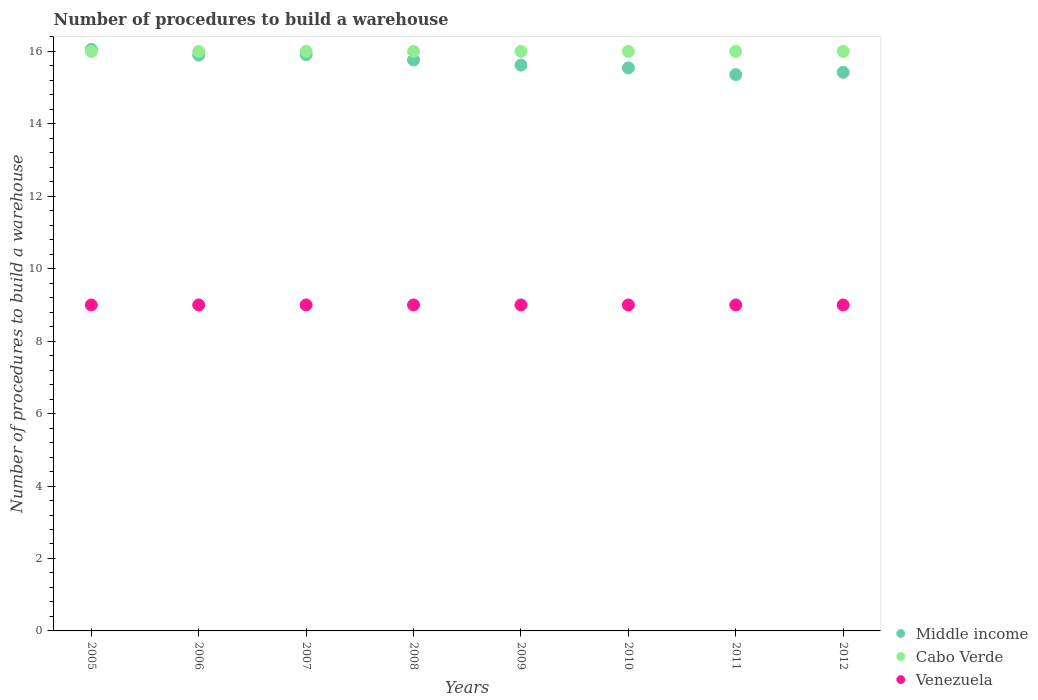How many different coloured dotlines are there?
Give a very brief answer. 3. Is the number of dotlines equal to the number of legend labels?
Provide a succinct answer. Yes. What is the number of procedures to build a warehouse in in Venezuela in 2011?
Your answer should be compact. 9. Across all years, what is the maximum number of procedures to build a warehouse in in Venezuela?
Provide a short and direct response. 9. Across all years, what is the minimum number of procedures to build a warehouse in in Venezuela?
Your answer should be very brief. 9. What is the total number of procedures to build a warehouse in in Middle income in the graph?
Make the answer very short. 125.58. What is the difference between the number of procedures to build a warehouse in in Middle income in 2009 and that in 2010?
Ensure brevity in your answer.  0.08. What is the difference between the number of procedures to build a warehouse in in Middle income in 2008 and the number of procedures to build a warehouse in in Venezuela in 2010?
Give a very brief answer. 6.76. What is the average number of procedures to build a warehouse in in Venezuela per year?
Your answer should be very brief. 9. In the year 2009, what is the difference between the number of procedures to build a warehouse in in Cabo Verde and number of procedures to build a warehouse in in Venezuela?
Give a very brief answer. 7. Is the number of procedures to build a warehouse in in Middle income in 2005 less than that in 2010?
Your answer should be compact. No. Is the difference between the number of procedures to build a warehouse in in Cabo Verde in 2009 and 2012 greater than the difference between the number of procedures to build a warehouse in in Venezuela in 2009 and 2012?
Offer a terse response. No. What is the difference between the highest and the second highest number of procedures to build a warehouse in in Cabo Verde?
Keep it short and to the point. 0. What is the difference between the highest and the lowest number of procedures to build a warehouse in in Venezuela?
Give a very brief answer. 0. Is it the case that in every year, the sum of the number of procedures to build a warehouse in in Cabo Verde and number of procedures to build a warehouse in in Middle income  is greater than the number of procedures to build a warehouse in in Venezuela?
Give a very brief answer. Yes. Is the number of procedures to build a warehouse in in Middle income strictly less than the number of procedures to build a warehouse in in Cabo Verde over the years?
Ensure brevity in your answer.  No. How many dotlines are there?
Provide a short and direct response. 3. Are the values on the major ticks of Y-axis written in scientific E-notation?
Provide a short and direct response. No. Does the graph contain any zero values?
Offer a terse response. No. Does the graph contain grids?
Ensure brevity in your answer.  No. Where does the legend appear in the graph?
Your answer should be compact. Bottom right. How are the legend labels stacked?
Give a very brief answer. Vertical. What is the title of the graph?
Provide a succinct answer. Number of procedures to build a warehouse. Does "Suriname" appear as one of the legend labels in the graph?
Your response must be concise. No. What is the label or title of the Y-axis?
Keep it short and to the point. Number of procedures to build a warehouse. What is the Number of procedures to build a warehouse of Middle income in 2005?
Offer a very short reply. 16.06. What is the Number of procedures to build a warehouse in Middle income in 2006?
Provide a succinct answer. 15.9. What is the Number of procedures to build a warehouse of Cabo Verde in 2006?
Give a very brief answer. 16. What is the Number of procedures to build a warehouse in Middle income in 2007?
Your answer should be very brief. 15.91. What is the Number of procedures to build a warehouse of Cabo Verde in 2007?
Give a very brief answer. 16. What is the Number of procedures to build a warehouse of Venezuela in 2007?
Your answer should be very brief. 9. What is the Number of procedures to build a warehouse in Middle income in 2008?
Your answer should be compact. 15.76. What is the Number of procedures to build a warehouse in Middle income in 2009?
Your answer should be very brief. 15.62. What is the Number of procedures to build a warehouse in Middle income in 2010?
Give a very brief answer. 15.54. What is the Number of procedures to build a warehouse in Venezuela in 2010?
Offer a terse response. 9. What is the Number of procedures to build a warehouse of Middle income in 2011?
Your response must be concise. 15.36. What is the Number of procedures to build a warehouse of Cabo Verde in 2011?
Provide a succinct answer. 16. What is the Number of procedures to build a warehouse in Venezuela in 2011?
Your answer should be very brief. 9. What is the Number of procedures to build a warehouse in Middle income in 2012?
Give a very brief answer. 15.42. What is the Number of procedures to build a warehouse of Venezuela in 2012?
Offer a very short reply. 9. Across all years, what is the maximum Number of procedures to build a warehouse in Middle income?
Provide a short and direct response. 16.06. Across all years, what is the maximum Number of procedures to build a warehouse of Cabo Verde?
Keep it short and to the point. 16. Across all years, what is the minimum Number of procedures to build a warehouse of Middle income?
Keep it short and to the point. 15.36. What is the total Number of procedures to build a warehouse of Middle income in the graph?
Keep it short and to the point. 125.58. What is the total Number of procedures to build a warehouse in Cabo Verde in the graph?
Make the answer very short. 128. What is the difference between the Number of procedures to build a warehouse in Middle income in 2005 and that in 2006?
Offer a very short reply. 0.16. What is the difference between the Number of procedures to build a warehouse of Venezuela in 2005 and that in 2006?
Give a very brief answer. 0. What is the difference between the Number of procedures to build a warehouse of Middle income in 2005 and that in 2007?
Make the answer very short. 0.15. What is the difference between the Number of procedures to build a warehouse in Middle income in 2005 and that in 2008?
Provide a succinct answer. 0.29. What is the difference between the Number of procedures to build a warehouse in Middle income in 2005 and that in 2009?
Provide a short and direct response. 0.43. What is the difference between the Number of procedures to build a warehouse of Middle income in 2005 and that in 2010?
Make the answer very short. 0.51. What is the difference between the Number of procedures to build a warehouse in Cabo Verde in 2005 and that in 2010?
Make the answer very short. 0. What is the difference between the Number of procedures to build a warehouse of Venezuela in 2005 and that in 2010?
Your answer should be very brief. 0. What is the difference between the Number of procedures to build a warehouse of Middle income in 2005 and that in 2011?
Keep it short and to the point. 0.7. What is the difference between the Number of procedures to build a warehouse in Cabo Verde in 2005 and that in 2011?
Offer a very short reply. 0. What is the difference between the Number of procedures to build a warehouse of Venezuela in 2005 and that in 2011?
Give a very brief answer. 0. What is the difference between the Number of procedures to build a warehouse in Middle income in 2005 and that in 2012?
Ensure brevity in your answer.  0.63. What is the difference between the Number of procedures to build a warehouse in Middle income in 2006 and that in 2007?
Your response must be concise. -0.01. What is the difference between the Number of procedures to build a warehouse in Venezuela in 2006 and that in 2007?
Keep it short and to the point. 0. What is the difference between the Number of procedures to build a warehouse of Middle income in 2006 and that in 2008?
Provide a succinct answer. 0.13. What is the difference between the Number of procedures to build a warehouse of Cabo Verde in 2006 and that in 2008?
Offer a very short reply. 0. What is the difference between the Number of procedures to build a warehouse of Middle income in 2006 and that in 2009?
Your answer should be very brief. 0.28. What is the difference between the Number of procedures to build a warehouse in Middle income in 2006 and that in 2010?
Keep it short and to the point. 0.35. What is the difference between the Number of procedures to build a warehouse of Cabo Verde in 2006 and that in 2010?
Your answer should be very brief. 0. What is the difference between the Number of procedures to build a warehouse of Venezuela in 2006 and that in 2010?
Offer a very short reply. 0. What is the difference between the Number of procedures to build a warehouse in Middle income in 2006 and that in 2011?
Keep it short and to the point. 0.54. What is the difference between the Number of procedures to build a warehouse of Middle income in 2006 and that in 2012?
Offer a terse response. 0.48. What is the difference between the Number of procedures to build a warehouse of Cabo Verde in 2006 and that in 2012?
Your answer should be compact. 0. What is the difference between the Number of procedures to build a warehouse of Venezuela in 2006 and that in 2012?
Make the answer very short. 0. What is the difference between the Number of procedures to build a warehouse of Middle income in 2007 and that in 2008?
Give a very brief answer. 0.15. What is the difference between the Number of procedures to build a warehouse of Middle income in 2007 and that in 2009?
Offer a very short reply. 0.29. What is the difference between the Number of procedures to build a warehouse of Venezuela in 2007 and that in 2009?
Ensure brevity in your answer.  0. What is the difference between the Number of procedures to build a warehouse of Middle income in 2007 and that in 2010?
Your response must be concise. 0.37. What is the difference between the Number of procedures to build a warehouse of Venezuela in 2007 and that in 2010?
Provide a short and direct response. 0. What is the difference between the Number of procedures to build a warehouse of Middle income in 2007 and that in 2011?
Offer a terse response. 0.55. What is the difference between the Number of procedures to build a warehouse of Venezuela in 2007 and that in 2011?
Provide a short and direct response. 0. What is the difference between the Number of procedures to build a warehouse in Middle income in 2007 and that in 2012?
Your answer should be compact. 0.49. What is the difference between the Number of procedures to build a warehouse in Cabo Verde in 2007 and that in 2012?
Provide a short and direct response. 0. What is the difference between the Number of procedures to build a warehouse of Venezuela in 2007 and that in 2012?
Your answer should be compact. 0. What is the difference between the Number of procedures to build a warehouse in Middle income in 2008 and that in 2009?
Keep it short and to the point. 0.14. What is the difference between the Number of procedures to build a warehouse in Cabo Verde in 2008 and that in 2009?
Your response must be concise. 0. What is the difference between the Number of procedures to build a warehouse in Middle income in 2008 and that in 2010?
Offer a very short reply. 0.22. What is the difference between the Number of procedures to build a warehouse in Cabo Verde in 2008 and that in 2010?
Keep it short and to the point. 0. What is the difference between the Number of procedures to build a warehouse in Venezuela in 2008 and that in 2010?
Provide a short and direct response. 0. What is the difference between the Number of procedures to build a warehouse in Middle income in 2008 and that in 2011?
Make the answer very short. 0.4. What is the difference between the Number of procedures to build a warehouse of Middle income in 2008 and that in 2012?
Your response must be concise. 0.34. What is the difference between the Number of procedures to build a warehouse in Cabo Verde in 2008 and that in 2012?
Ensure brevity in your answer.  0. What is the difference between the Number of procedures to build a warehouse of Middle income in 2009 and that in 2010?
Ensure brevity in your answer.  0.08. What is the difference between the Number of procedures to build a warehouse of Venezuela in 2009 and that in 2010?
Offer a very short reply. 0. What is the difference between the Number of procedures to build a warehouse in Middle income in 2009 and that in 2011?
Make the answer very short. 0.26. What is the difference between the Number of procedures to build a warehouse of Cabo Verde in 2009 and that in 2011?
Offer a very short reply. 0. What is the difference between the Number of procedures to build a warehouse of Venezuela in 2009 and that in 2011?
Your response must be concise. 0. What is the difference between the Number of procedures to build a warehouse of Cabo Verde in 2009 and that in 2012?
Offer a very short reply. 0. What is the difference between the Number of procedures to build a warehouse in Middle income in 2010 and that in 2011?
Your answer should be very brief. 0.18. What is the difference between the Number of procedures to build a warehouse in Venezuela in 2010 and that in 2011?
Provide a short and direct response. 0. What is the difference between the Number of procedures to build a warehouse in Middle income in 2010 and that in 2012?
Offer a terse response. 0.12. What is the difference between the Number of procedures to build a warehouse of Cabo Verde in 2010 and that in 2012?
Your answer should be very brief. 0. What is the difference between the Number of procedures to build a warehouse of Venezuela in 2010 and that in 2012?
Offer a very short reply. 0. What is the difference between the Number of procedures to build a warehouse of Middle income in 2011 and that in 2012?
Offer a very short reply. -0.06. What is the difference between the Number of procedures to build a warehouse of Cabo Verde in 2011 and that in 2012?
Your response must be concise. 0. What is the difference between the Number of procedures to build a warehouse of Middle income in 2005 and the Number of procedures to build a warehouse of Cabo Verde in 2006?
Your answer should be very brief. 0.06. What is the difference between the Number of procedures to build a warehouse in Middle income in 2005 and the Number of procedures to build a warehouse in Venezuela in 2006?
Provide a succinct answer. 7.06. What is the difference between the Number of procedures to build a warehouse of Middle income in 2005 and the Number of procedures to build a warehouse of Cabo Verde in 2007?
Your answer should be compact. 0.06. What is the difference between the Number of procedures to build a warehouse of Middle income in 2005 and the Number of procedures to build a warehouse of Venezuela in 2007?
Your answer should be very brief. 7.06. What is the difference between the Number of procedures to build a warehouse of Cabo Verde in 2005 and the Number of procedures to build a warehouse of Venezuela in 2007?
Offer a very short reply. 7. What is the difference between the Number of procedures to build a warehouse of Middle income in 2005 and the Number of procedures to build a warehouse of Cabo Verde in 2008?
Give a very brief answer. 0.06. What is the difference between the Number of procedures to build a warehouse of Middle income in 2005 and the Number of procedures to build a warehouse of Venezuela in 2008?
Keep it short and to the point. 7.06. What is the difference between the Number of procedures to build a warehouse in Cabo Verde in 2005 and the Number of procedures to build a warehouse in Venezuela in 2008?
Give a very brief answer. 7. What is the difference between the Number of procedures to build a warehouse in Middle income in 2005 and the Number of procedures to build a warehouse in Cabo Verde in 2009?
Offer a very short reply. 0.06. What is the difference between the Number of procedures to build a warehouse in Middle income in 2005 and the Number of procedures to build a warehouse in Venezuela in 2009?
Your response must be concise. 7.06. What is the difference between the Number of procedures to build a warehouse in Middle income in 2005 and the Number of procedures to build a warehouse in Cabo Verde in 2010?
Offer a terse response. 0.06. What is the difference between the Number of procedures to build a warehouse of Middle income in 2005 and the Number of procedures to build a warehouse of Venezuela in 2010?
Offer a very short reply. 7.06. What is the difference between the Number of procedures to build a warehouse of Middle income in 2005 and the Number of procedures to build a warehouse of Cabo Verde in 2011?
Ensure brevity in your answer.  0.06. What is the difference between the Number of procedures to build a warehouse of Middle income in 2005 and the Number of procedures to build a warehouse of Venezuela in 2011?
Ensure brevity in your answer.  7.06. What is the difference between the Number of procedures to build a warehouse of Cabo Verde in 2005 and the Number of procedures to build a warehouse of Venezuela in 2011?
Provide a short and direct response. 7. What is the difference between the Number of procedures to build a warehouse of Middle income in 2005 and the Number of procedures to build a warehouse of Cabo Verde in 2012?
Make the answer very short. 0.06. What is the difference between the Number of procedures to build a warehouse in Middle income in 2005 and the Number of procedures to build a warehouse in Venezuela in 2012?
Give a very brief answer. 7.06. What is the difference between the Number of procedures to build a warehouse of Middle income in 2006 and the Number of procedures to build a warehouse of Cabo Verde in 2007?
Keep it short and to the point. -0.1. What is the difference between the Number of procedures to build a warehouse of Middle income in 2006 and the Number of procedures to build a warehouse of Venezuela in 2007?
Provide a succinct answer. 6.9. What is the difference between the Number of procedures to build a warehouse in Cabo Verde in 2006 and the Number of procedures to build a warehouse in Venezuela in 2007?
Offer a very short reply. 7. What is the difference between the Number of procedures to build a warehouse in Middle income in 2006 and the Number of procedures to build a warehouse in Cabo Verde in 2008?
Offer a terse response. -0.1. What is the difference between the Number of procedures to build a warehouse in Middle income in 2006 and the Number of procedures to build a warehouse in Venezuela in 2008?
Your response must be concise. 6.9. What is the difference between the Number of procedures to build a warehouse in Cabo Verde in 2006 and the Number of procedures to build a warehouse in Venezuela in 2008?
Offer a terse response. 7. What is the difference between the Number of procedures to build a warehouse of Middle income in 2006 and the Number of procedures to build a warehouse of Cabo Verde in 2009?
Provide a short and direct response. -0.1. What is the difference between the Number of procedures to build a warehouse in Middle income in 2006 and the Number of procedures to build a warehouse in Venezuela in 2009?
Provide a succinct answer. 6.9. What is the difference between the Number of procedures to build a warehouse in Middle income in 2006 and the Number of procedures to build a warehouse in Cabo Verde in 2010?
Your answer should be compact. -0.1. What is the difference between the Number of procedures to build a warehouse in Middle income in 2006 and the Number of procedures to build a warehouse in Venezuela in 2010?
Give a very brief answer. 6.9. What is the difference between the Number of procedures to build a warehouse of Middle income in 2006 and the Number of procedures to build a warehouse of Cabo Verde in 2011?
Your response must be concise. -0.1. What is the difference between the Number of procedures to build a warehouse of Middle income in 2006 and the Number of procedures to build a warehouse of Venezuela in 2011?
Provide a short and direct response. 6.9. What is the difference between the Number of procedures to build a warehouse of Cabo Verde in 2006 and the Number of procedures to build a warehouse of Venezuela in 2011?
Offer a very short reply. 7. What is the difference between the Number of procedures to build a warehouse of Middle income in 2006 and the Number of procedures to build a warehouse of Cabo Verde in 2012?
Keep it short and to the point. -0.1. What is the difference between the Number of procedures to build a warehouse of Middle income in 2006 and the Number of procedures to build a warehouse of Venezuela in 2012?
Provide a short and direct response. 6.9. What is the difference between the Number of procedures to build a warehouse of Middle income in 2007 and the Number of procedures to build a warehouse of Cabo Verde in 2008?
Keep it short and to the point. -0.09. What is the difference between the Number of procedures to build a warehouse of Middle income in 2007 and the Number of procedures to build a warehouse of Venezuela in 2008?
Your answer should be very brief. 6.91. What is the difference between the Number of procedures to build a warehouse in Middle income in 2007 and the Number of procedures to build a warehouse in Cabo Verde in 2009?
Your answer should be compact. -0.09. What is the difference between the Number of procedures to build a warehouse in Middle income in 2007 and the Number of procedures to build a warehouse in Venezuela in 2009?
Give a very brief answer. 6.91. What is the difference between the Number of procedures to build a warehouse in Cabo Verde in 2007 and the Number of procedures to build a warehouse in Venezuela in 2009?
Your answer should be very brief. 7. What is the difference between the Number of procedures to build a warehouse in Middle income in 2007 and the Number of procedures to build a warehouse in Cabo Verde in 2010?
Provide a short and direct response. -0.09. What is the difference between the Number of procedures to build a warehouse of Middle income in 2007 and the Number of procedures to build a warehouse of Venezuela in 2010?
Make the answer very short. 6.91. What is the difference between the Number of procedures to build a warehouse in Cabo Verde in 2007 and the Number of procedures to build a warehouse in Venezuela in 2010?
Your response must be concise. 7. What is the difference between the Number of procedures to build a warehouse in Middle income in 2007 and the Number of procedures to build a warehouse in Cabo Verde in 2011?
Offer a very short reply. -0.09. What is the difference between the Number of procedures to build a warehouse in Middle income in 2007 and the Number of procedures to build a warehouse in Venezuela in 2011?
Your response must be concise. 6.91. What is the difference between the Number of procedures to build a warehouse of Cabo Verde in 2007 and the Number of procedures to build a warehouse of Venezuela in 2011?
Keep it short and to the point. 7. What is the difference between the Number of procedures to build a warehouse of Middle income in 2007 and the Number of procedures to build a warehouse of Cabo Verde in 2012?
Provide a short and direct response. -0.09. What is the difference between the Number of procedures to build a warehouse of Middle income in 2007 and the Number of procedures to build a warehouse of Venezuela in 2012?
Keep it short and to the point. 6.91. What is the difference between the Number of procedures to build a warehouse of Cabo Verde in 2007 and the Number of procedures to build a warehouse of Venezuela in 2012?
Provide a short and direct response. 7. What is the difference between the Number of procedures to build a warehouse in Middle income in 2008 and the Number of procedures to build a warehouse in Cabo Verde in 2009?
Provide a succinct answer. -0.24. What is the difference between the Number of procedures to build a warehouse in Middle income in 2008 and the Number of procedures to build a warehouse in Venezuela in 2009?
Offer a very short reply. 6.76. What is the difference between the Number of procedures to build a warehouse of Cabo Verde in 2008 and the Number of procedures to build a warehouse of Venezuela in 2009?
Offer a very short reply. 7. What is the difference between the Number of procedures to build a warehouse in Middle income in 2008 and the Number of procedures to build a warehouse in Cabo Verde in 2010?
Your response must be concise. -0.24. What is the difference between the Number of procedures to build a warehouse in Middle income in 2008 and the Number of procedures to build a warehouse in Venezuela in 2010?
Offer a terse response. 6.76. What is the difference between the Number of procedures to build a warehouse of Middle income in 2008 and the Number of procedures to build a warehouse of Cabo Verde in 2011?
Offer a terse response. -0.24. What is the difference between the Number of procedures to build a warehouse of Middle income in 2008 and the Number of procedures to build a warehouse of Venezuela in 2011?
Offer a very short reply. 6.76. What is the difference between the Number of procedures to build a warehouse in Middle income in 2008 and the Number of procedures to build a warehouse in Cabo Verde in 2012?
Your response must be concise. -0.24. What is the difference between the Number of procedures to build a warehouse of Middle income in 2008 and the Number of procedures to build a warehouse of Venezuela in 2012?
Ensure brevity in your answer.  6.76. What is the difference between the Number of procedures to build a warehouse in Middle income in 2009 and the Number of procedures to build a warehouse in Cabo Verde in 2010?
Ensure brevity in your answer.  -0.38. What is the difference between the Number of procedures to build a warehouse in Middle income in 2009 and the Number of procedures to build a warehouse in Venezuela in 2010?
Your answer should be compact. 6.62. What is the difference between the Number of procedures to build a warehouse in Middle income in 2009 and the Number of procedures to build a warehouse in Cabo Verde in 2011?
Give a very brief answer. -0.38. What is the difference between the Number of procedures to build a warehouse of Middle income in 2009 and the Number of procedures to build a warehouse of Venezuela in 2011?
Make the answer very short. 6.62. What is the difference between the Number of procedures to build a warehouse in Cabo Verde in 2009 and the Number of procedures to build a warehouse in Venezuela in 2011?
Give a very brief answer. 7. What is the difference between the Number of procedures to build a warehouse of Middle income in 2009 and the Number of procedures to build a warehouse of Cabo Verde in 2012?
Offer a terse response. -0.38. What is the difference between the Number of procedures to build a warehouse of Middle income in 2009 and the Number of procedures to build a warehouse of Venezuela in 2012?
Your answer should be compact. 6.62. What is the difference between the Number of procedures to build a warehouse in Middle income in 2010 and the Number of procedures to build a warehouse in Cabo Verde in 2011?
Your response must be concise. -0.46. What is the difference between the Number of procedures to build a warehouse of Middle income in 2010 and the Number of procedures to build a warehouse of Venezuela in 2011?
Your response must be concise. 6.54. What is the difference between the Number of procedures to build a warehouse in Cabo Verde in 2010 and the Number of procedures to build a warehouse in Venezuela in 2011?
Offer a terse response. 7. What is the difference between the Number of procedures to build a warehouse in Middle income in 2010 and the Number of procedures to build a warehouse in Cabo Verde in 2012?
Your answer should be very brief. -0.46. What is the difference between the Number of procedures to build a warehouse in Middle income in 2010 and the Number of procedures to build a warehouse in Venezuela in 2012?
Provide a short and direct response. 6.54. What is the difference between the Number of procedures to build a warehouse of Middle income in 2011 and the Number of procedures to build a warehouse of Cabo Verde in 2012?
Your answer should be compact. -0.64. What is the difference between the Number of procedures to build a warehouse in Middle income in 2011 and the Number of procedures to build a warehouse in Venezuela in 2012?
Make the answer very short. 6.36. What is the average Number of procedures to build a warehouse in Middle income per year?
Your response must be concise. 15.7. What is the average Number of procedures to build a warehouse of Cabo Verde per year?
Make the answer very short. 16. What is the average Number of procedures to build a warehouse in Venezuela per year?
Your answer should be compact. 9. In the year 2005, what is the difference between the Number of procedures to build a warehouse of Middle income and Number of procedures to build a warehouse of Cabo Verde?
Your response must be concise. 0.06. In the year 2005, what is the difference between the Number of procedures to build a warehouse of Middle income and Number of procedures to build a warehouse of Venezuela?
Provide a short and direct response. 7.06. In the year 2006, what is the difference between the Number of procedures to build a warehouse in Middle income and Number of procedures to build a warehouse in Cabo Verde?
Provide a succinct answer. -0.1. In the year 2006, what is the difference between the Number of procedures to build a warehouse in Middle income and Number of procedures to build a warehouse in Venezuela?
Your answer should be compact. 6.9. In the year 2006, what is the difference between the Number of procedures to build a warehouse of Cabo Verde and Number of procedures to build a warehouse of Venezuela?
Your answer should be very brief. 7. In the year 2007, what is the difference between the Number of procedures to build a warehouse of Middle income and Number of procedures to build a warehouse of Cabo Verde?
Offer a terse response. -0.09. In the year 2007, what is the difference between the Number of procedures to build a warehouse of Middle income and Number of procedures to build a warehouse of Venezuela?
Ensure brevity in your answer.  6.91. In the year 2008, what is the difference between the Number of procedures to build a warehouse of Middle income and Number of procedures to build a warehouse of Cabo Verde?
Keep it short and to the point. -0.24. In the year 2008, what is the difference between the Number of procedures to build a warehouse of Middle income and Number of procedures to build a warehouse of Venezuela?
Your answer should be very brief. 6.76. In the year 2009, what is the difference between the Number of procedures to build a warehouse in Middle income and Number of procedures to build a warehouse in Cabo Verde?
Offer a terse response. -0.38. In the year 2009, what is the difference between the Number of procedures to build a warehouse of Middle income and Number of procedures to build a warehouse of Venezuela?
Make the answer very short. 6.62. In the year 2010, what is the difference between the Number of procedures to build a warehouse in Middle income and Number of procedures to build a warehouse in Cabo Verde?
Ensure brevity in your answer.  -0.46. In the year 2010, what is the difference between the Number of procedures to build a warehouse in Middle income and Number of procedures to build a warehouse in Venezuela?
Give a very brief answer. 6.54. In the year 2010, what is the difference between the Number of procedures to build a warehouse in Cabo Verde and Number of procedures to build a warehouse in Venezuela?
Provide a short and direct response. 7. In the year 2011, what is the difference between the Number of procedures to build a warehouse in Middle income and Number of procedures to build a warehouse in Cabo Verde?
Your answer should be compact. -0.64. In the year 2011, what is the difference between the Number of procedures to build a warehouse of Middle income and Number of procedures to build a warehouse of Venezuela?
Your response must be concise. 6.36. In the year 2012, what is the difference between the Number of procedures to build a warehouse in Middle income and Number of procedures to build a warehouse in Cabo Verde?
Keep it short and to the point. -0.58. In the year 2012, what is the difference between the Number of procedures to build a warehouse in Middle income and Number of procedures to build a warehouse in Venezuela?
Make the answer very short. 6.42. In the year 2012, what is the difference between the Number of procedures to build a warehouse in Cabo Verde and Number of procedures to build a warehouse in Venezuela?
Give a very brief answer. 7. What is the ratio of the Number of procedures to build a warehouse in Middle income in 2005 to that in 2006?
Provide a succinct answer. 1.01. What is the ratio of the Number of procedures to build a warehouse of Cabo Verde in 2005 to that in 2006?
Make the answer very short. 1. What is the ratio of the Number of procedures to build a warehouse of Venezuela in 2005 to that in 2006?
Your answer should be very brief. 1. What is the ratio of the Number of procedures to build a warehouse of Middle income in 2005 to that in 2007?
Give a very brief answer. 1.01. What is the ratio of the Number of procedures to build a warehouse of Cabo Verde in 2005 to that in 2007?
Your answer should be very brief. 1. What is the ratio of the Number of procedures to build a warehouse in Middle income in 2005 to that in 2008?
Your response must be concise. 1.02. What is the ratio of the Number of procedures to build a warehouse of Middle income in 2005 to that in 2009?
Your response must be concise. 1.03. What is the ratio of the Number of procedures to build a warehouse of Venezuela in 2005 to that in 2009?
Offer a terse response. 1. What is the ratio of the Number of procedures to build a warehouse of Middle income in 2005 to that in 2010?
Offer a terse response. 1.03. What is the ratio of the Number of procedures to build a warehouse in Cabo Verde in 2005 to that in 2010?
Give a very brief answer. 1. What is the ratio of the Number of procedures to build a warehouse of Middle income in 2005 to that in 2011?
Offer a very short reply. 1.05. What is the ratio of the Number of procedures to build a warehouse of Cabo Verde in 2005 to that in 2011?
Give a very brief answer. 1. What is the ratio of the Number of procedures to build a warehouse of Venezuela in 2005 to that in 2011?
Offer a very short reply. 1. What is the ratio of the Number of procedures to build a warehouse in Middle income in 2005 to that in 2012?
Make the answer very short. 1.04. What is the ratio of the Number of procedures to build a warehouse of Cabo Verde in 2006 to that in 2007?
Ensure brevity in your answer.  1. What is the ratio of the Number of procedures to build a warehouse of Venezuela in 2006 to that in 2007?
Offer a very short reply. 1. What is the ratio of the Number of procedures to build a warehouse of Middle income in 2006 to that in 2008?
Your answer should be very brief. 1.01. What is the ratio of the Number of procedures to build a warehouse of Venezuela in 2006 to that in 2008?
Keep it short and to the point. 1. What is the ratio of the Number of procedures to build a warehouse in Middle income in 2006 to that in 2009?
Offer a very short reply. 1.02. What is the ratio of the Number of procedures to build a warehouse in Cabo Verde in 2006 to that in 2009?
Offer a terse response. 1. What is the ratio of the Number of procedures to build a warehouse of Middle income in 2006 to that in 2010?
Your answer should be very brief. 1.02. What is the ratio of the Number of procedures to build a warehouse of Middle income in 2006 to that in 2011?
Your answer should be compact. 1.04. What is the ratio of the Number of procedures to build a warehouse in Cabo Verde in 2006 to that in 2011?
Give a very brief answer. 1. What is the ratio of the Number of procedures to build a warehouse of Venezuela in 2006 to that in 2011?
Your answer should be very brief. 1. What is the ratio of the Number of procedures to build a warehouse of Middle income in 2006 to that in 2012?
Offer a very short reply. 1.03. What is the ratio of the Number of procedures to build a warehouse of Middle income in 2007 to that in 2008?
Ensure brevity in your answer.  1.01. What is the ratio of the Number of procedures to build a warehouse of Cabo Verde in 2007 to that in 2008?
Give a very brief answer. 1. What is the ratio of the Number of procedures to build a warehouse of Middle income in 2007 to that in 2009?
Make the answer very short. 1.02. What is the ratio of the Number of procedures to build a warehouse of Venezuela in 2007 to that in 2009?
Your answer should be compact. 1. What is the ratio of the Number of procedures to build a warehouse of Middle income in 2007 to that in 2010?
Your response must be concise. 1.02. What is the ratio of the Number of procedures to build a warehouse of Cabo Verde in 2007 to that in 2010?
Make the answer very short. 1. What is the ratio of the Number of procedures to build a warehouse in Middle income in 2007 to that in 2011?
Your answer should be very brief. 1.04. What is the ratio of the Number of procedures to build a warehouse of Middle income in 2007 to that in 2012?
Keep it short and to the point. 1.03. What is the ratio of the Number of procedures to build a warehouse in Middle income in 2008 to that in 2009?
Your response must be concise. 1.01. What is the ratio of the Number of procedures to build a warehouse in Cabo Verde in 2008 to that in 2009?
Give a very brief answer. 1. What is the ratio of the Number of procedures to build a warehouse of Venezuela in 2008 to that in 2009?
Offer a very short reply. 1. What is the ratio of the Number of procedures to build a warehouse in Middle income in 2008 to that in 2010?
Offer a very short reply. 1.01. What is the ratio of the Number of procedures to build a warehouse in Venezuela in 2008 to that in 2010?
Your answer should be very brief. 1. What is the ratio of the Number of procedures to build a warehouse of Middle income in 2008 to that in 2011?
Make the answer very short. 1.03. What is the ratio of the Number of procedures to build a warehouse in Venezuela in 2008 to that in 2011?
Your response must be concise. 1. What is the ratio of the Number of procedures to build a warehouse in Middle income in 2008 to that in 2012?
Provide a short and direct response. 1.02. What is the ratio of the Number of procedures to build a warehouse of Cabo Verde in 2008 to that in 2012?
Your answer should be very brief. 1. What is the ratio of the Number of procedures to build a warehouse of Venezuela in 2008 to that in 2012?
Offer a terse response. 1. What is the ratio of the Number of procedures to build a warehouse of Middle income in 2009 to that in 2010?
Keep it short and to the point. 1. What is the ratio of the Number of procedures to build a warehouse in Cabo Verde in 2009 to that in 2010?
Your answer should be very brief. 1. What is the ratio of the Number of procedures to build a warehouse of Middle income in 2009 to that in 2011?
Keep it short and to the point. 1.02. What is the ratio of the Number of procedures to build a warehouse of Cabo Verde in 2009 to that in 2011?
Keep it short and to the point. 1. What is the ratio of the Number of procedures to build a warehouse in Venezuela in 2009 to that in 2011?
Your answer should be very brief. 1. What is the ratio of the Number of procedures to build a warehouse of Venezuela in 2010 to that in 2011?
Keep it short and to the point. 1. What is the ratio of the Number of procedures to build a warehouse of Middle income in 2010 to that in 2012?
Offer a terse response. 1.01. What is the ratio of the Number of procedures to build a warehouse in Cabo Verde in 2010 to that in 2012?
Your answer should be very brief. 1. What is the ratio of the Number of procedures to build a warehouse of Cabo Verde in 2011 to that in 2012?
Ensure brevity in your answer.  1. What is the difference between the highest and the second highest Number of procedures to build a warehouse of Middle income?
Ensure brevity in your answer.  0.15. What is the difference between the highest and the second highest Number of procedures to build a warehouse of Cabo Verde?
Make the answer very short. 0. What is the difference between the highest and the lowest Number of procedures to build a warehouse in Middle income?
Your answer should be compact. 0.7. What is the difference between the highest and the lowest Number of procedures to build a warehouse in Cabo Verde?
Offer a very short reply. 0. What is the difference between the highest and the lowest Number of procedures to build a warehouse in Venezuela?
Give a very brief answer. 0. 